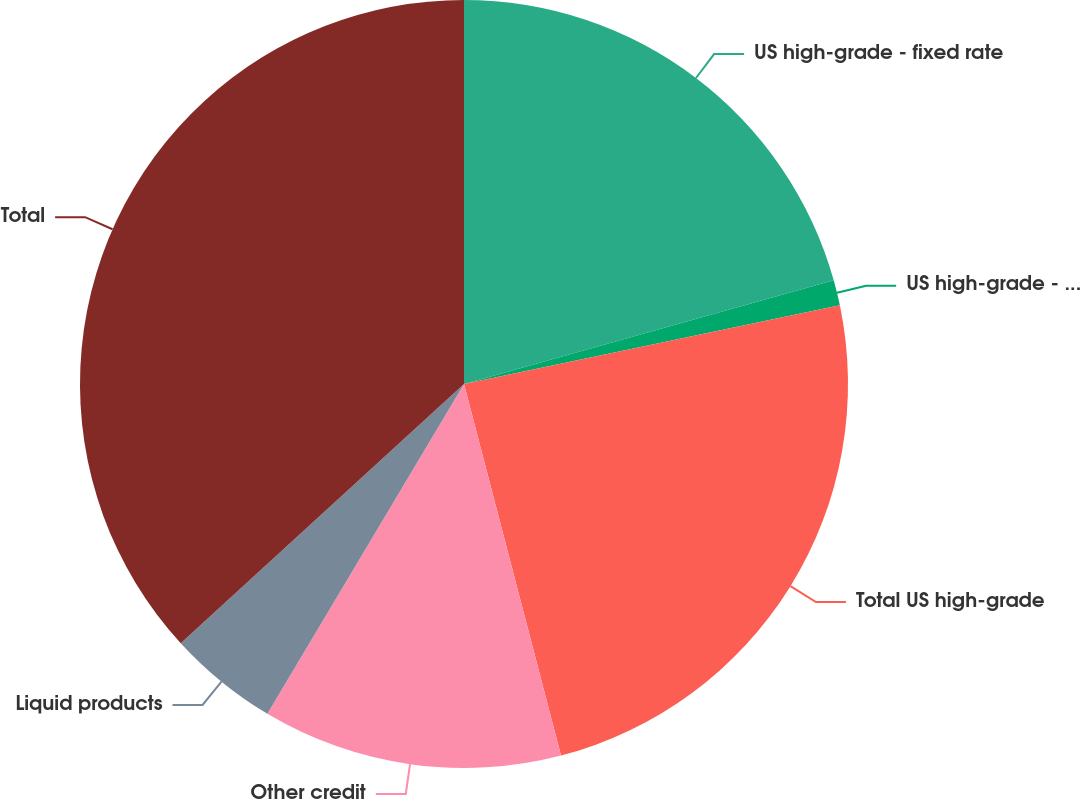Convert chart. <chart><loc_0><loc_0><loc_500><loc_500><pie_chart><fcel>US high-grade - fixed rate<fcel>US high-grade - floating rate<fcel>Total US high-grade<fcel>Other credit<fcel>Liquid products<fcel>Total<nl><fcel>20.65%<fcel>1.07%<fcel>24.22%<fcel>12.62%<fcel>4.65%<fcel>36.8%<nl></chart> 